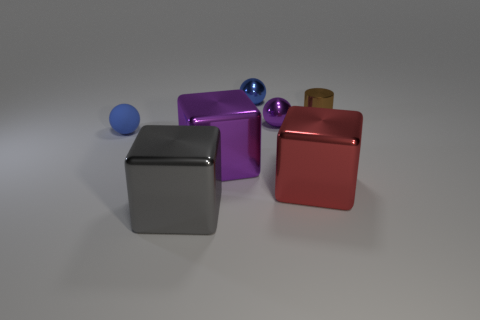There is a tiny matte ball; is it the same color as the metal thing that is behind the small brown shiny cylinder?
Offer a very short reply. Yes. The red thing that is the same material as the brown cylinder is what size?
Offer a terse response. Large. Is the number of small brown metallic cylinders that are behind the big purple metal cube greater than the number of big rubber cylinders?
Your answer should be compact. Yes. What material is the object that is right of the metallic block that is to the right of the blue ball on the right side of the big gray block?
Give a very brief answer. Metal. Are the brown cylinder and the big block behind the red block made of the same material?
Offer a terse response. Yes. What material is the red object that is the same shape as the big gray thing?
Offer a terse response. Metal. Are there more tiny blue balls that are behind the brown shiny thing than purple shiny cubes that are left of the big gray metallic object?
Your answer should be compact. Yes. The small purple thing that is made of the same material as the large red thing is what shape?
Ensure brevity in your answer.  Sphere. What number of other things are the same shape as the small brown shiny object?
Your response must be concise. 0. The brown metal object behind the big gray thing has what shape?
Your answer should be compact. Cylinder. 